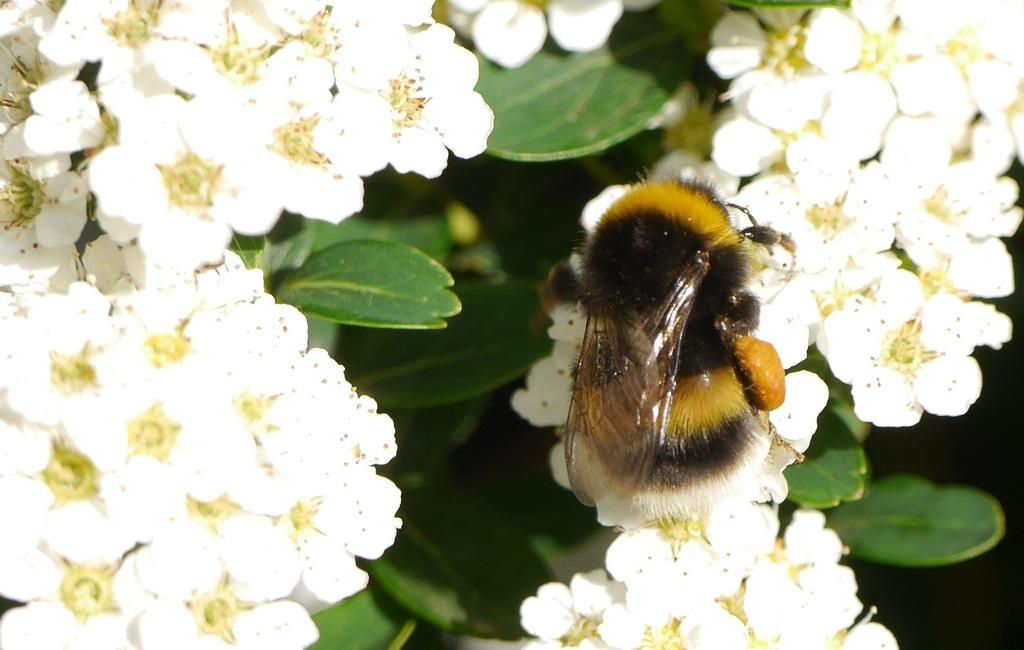What type of flowers are present in the image? There are white flowers in the image. What color are the leaves in the image? There are green leaves in the image. Can you describe any other living organisms in the image? Yes, there is an insect visible on a white flower. What type of needle is the doctor using to treat the goat in the image? There is no doctor or goat present in the image, and therefore no such activity can be observed. 